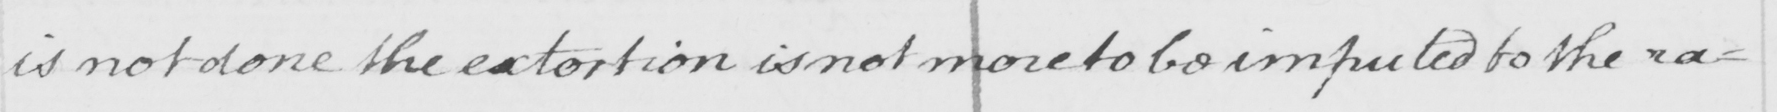What does this handwritten line say? is not done the extortion is not more to be imputed to the ra= 